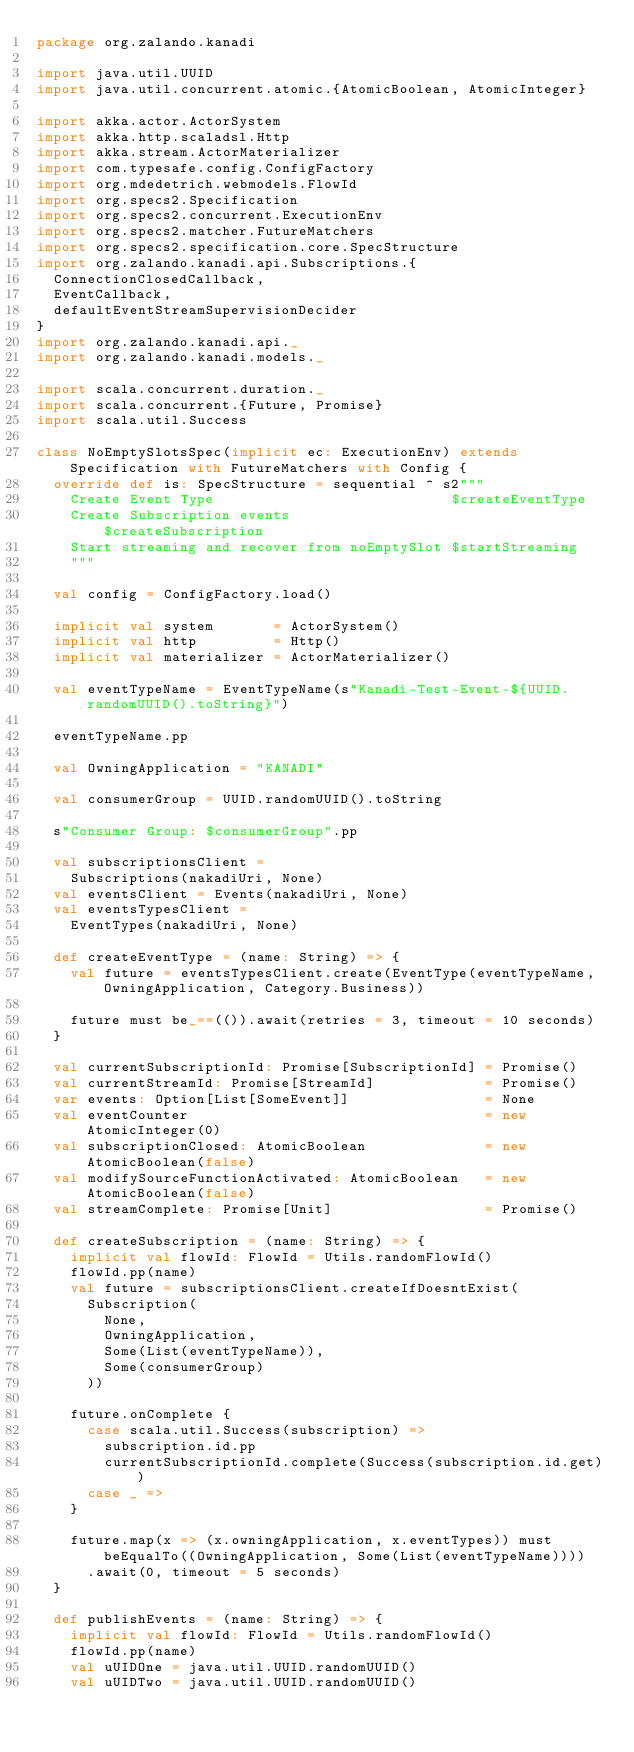Convert code to text. <code><loc_0><loc_0><loc_500><loc_500><_Scala_>package org.zalando.kanadi

import java.util.UUID
import java.util.concurrent.atomic.{AtomicBoolean, AtomicInteger}

import akka.actor.ActorSystem
import akka.http.scaladsl.Http
import akka.stream.ActorMaterializer
import com.typesafe.config.ConfigFactory
import org.mdedetrich.webmodels.FlowId
import org.specs2.Specification
import org.specs2.concurrent.ExecutionEnv
import org.specs2.matcher.FutureMatchers
import org.specs2.specification.core.SpecStructure
import org.zalando.kanadi.api.Subscriptions.{
  ConnectionClosedCallback,
  EventCallback,
  defaultEventStreamSupervisionDecider
}
import org.zalando.kanadi.api._
import org.zalando.kanadi.models._

import scala.concurrent.duration._
import scala.concurrent.{Future, Promise}
import scala.util.Success

class NoEmptySlotsSpec(implicit ec: ExecutionEnv) extends Specification with FutureMatchers with Config {
  override def is: SpecStructure = sequential ^ s2"""
    Create Event Type                            $createEventType
    Create Subscription events                   $createSubscription
    Start streaming and recover from noEmptySlot $startStreaming
    """

  val config = ConfigFactory.load()

  implicit val system       = ActorSystem()
  implicit val http         = Http()
  implicit val materializer = ActorMaterializer()

  val eventTypeName = EventTypeName(s"Kanadi-Test-Event-${UUID.randomUUID().toString}")

  eventTypeName.pp

  val OwningApplication = "KANADI"

  val consumerGroup = UUID.randomUUID().toString

  s"Consumer Group: $consumerGroup".pp

  val subscriptionsClient =
    Subscriptions(nakadiUri, None)
  val eventsClient = Events(nakadiUri, None)
  val eventsTypesClient =
    EventTypes(nakadiUri, None)

  def createEventType = (name: String) => {
    val future = eventsTypesClient.create(EventType(eventTypeName, OwningApplication, Category.Business))

    future must be_==(()).await(retries = 3, timeout = 10 seconds)
  }

  val currentSubscriptionId: Promise[SubscriptionId] = Promise()
  val currentStreamId: Promise[StreamId]             = Promise()
  var events: Option[List[SomeEvent]]                = None
  val eventCounter                                   = new AtomicInteger(0)
  val subscriptionClosed: AtomicBoolean              = new AtomicBoolean(false)
  val modifySourceFunctionActivated: AtomicBoolean   = new AtomicBoolean(false)
  val streamComplete: Promise[Unit]                  = Promise()

  def createSubscription = (name: String) => {
    implicit val flowId: FlowId = Utils.randomFlowId()
    flowId.pp(name)
    val future = subscriptionsClient.createIfDoesntExist(
      Subscription(
        None,
        OwningApplication,
        Some(List(eventTypeName)),
        Some(consumerGroup)
      ))

    future.onComplete {
      case scala.util.Success(subscription) =>
        subscription.id.pp
        currentSubscriptionId.complete(Success(subscription.id.get))
      case _ =>
    }

    future.map(x => (x.owningApplication, x.eventTypes)) must beEqualTo((OwningApplication, Some(List(eventTypeName))))
      .await(0, timeout = 5 seconds)
  }

  def publishEvents = (name: String) => {
    implicit val flowId: FlowId = Utils.randomFlowId()
    flowId.pp(name)
    val uUIDOne = java.util.UUID.randomUUID()
    val uUIDTwo = java.util.UUID.randomUUID()
</code> 